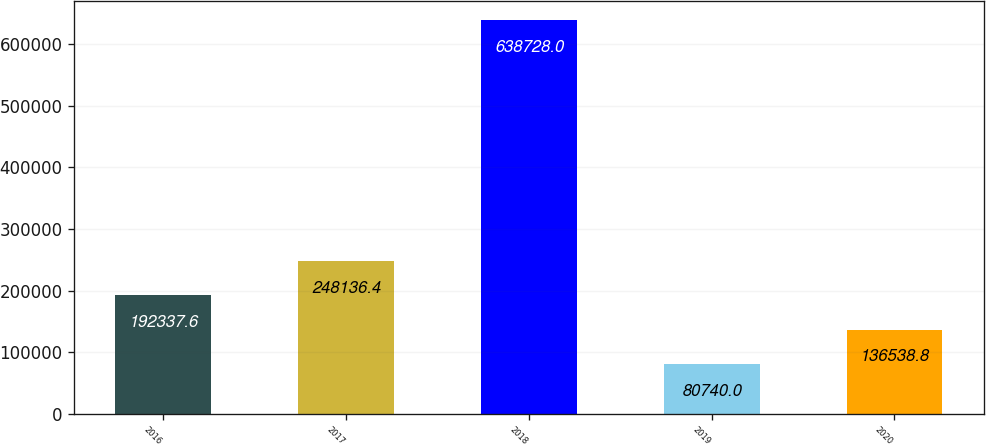Convert chart. <chart><loc_0><loc_0><loc_500><loc_500><bar_chart><fcel>2016<fcel>2017<fcel>2018<fcel>2019<fcel>2020<nl><fcel>192338<fcel>248136<fcel>638728<fcel>80740<fcel>136539<nl></chart> 